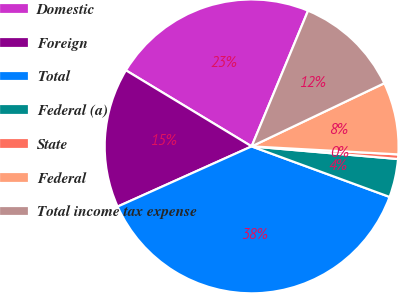<chart> <loc_0><loc_0><loc_500><loc_500><pie_chart><fcel>Domestic<fcel>Foreign<fcel>Total<fcel>Federal (a)<fcel>State<fcel>Federal<fcel>Total income tax expense<nl><fcel>22.61%<fcel>15.38%<fcel>37.69%<fcel>4.22%<fcel>0.5%<fcel>7.94%<fcel>11.66%<nl></chart> 